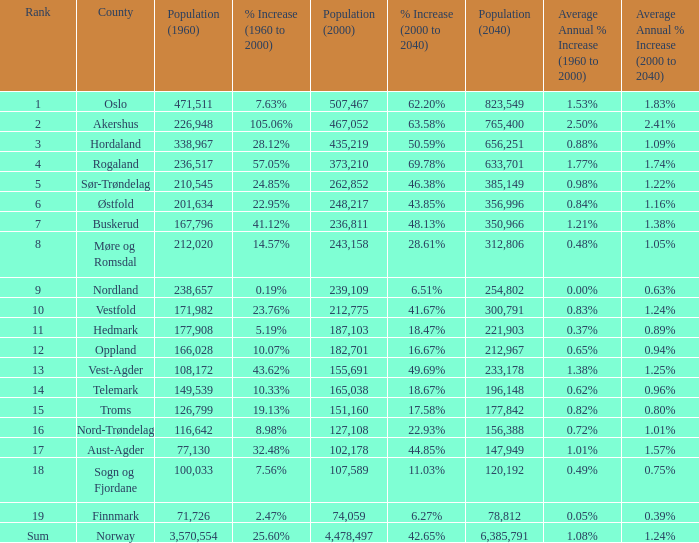What was Oslo's population in 1960, with a population of 507,467 in 2000? None. 